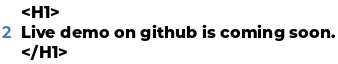Convert code to text. <code><loc_0><loc_0><loc_500><loc_500><_HTML_><H1>
Live demo on github is coming soon.
</H1>
</code> 